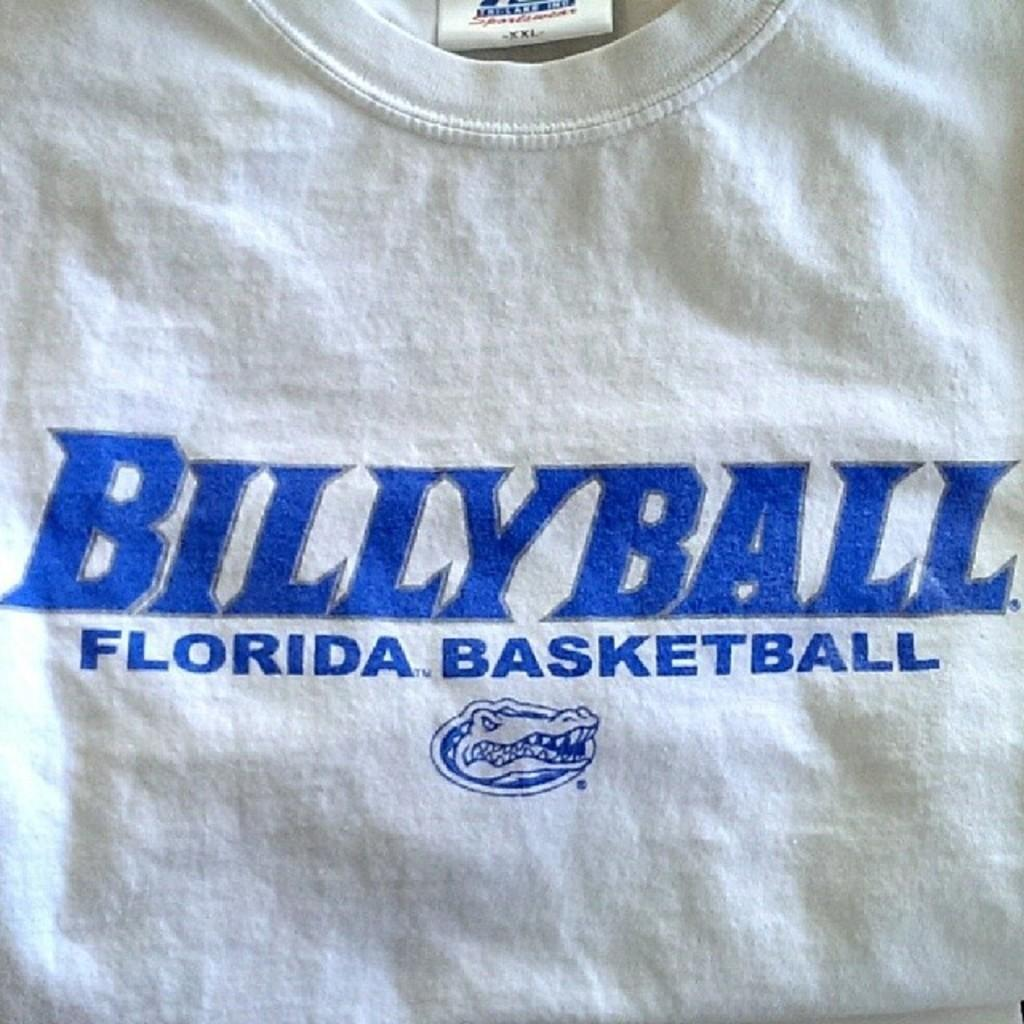<image>
Summarize the visual content of the image. The white t shirt is the Billy Ball team. 